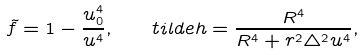Convert formula to latex. <formula><loc_0><loc_0><loc_500><loc_500>\tilde { f } = 1 - \frac { u _ { 0 } ^ { 4 } } { u ^ { 4 } } , \quad t i l d e h = \frac { R ^ { 4 } } { R ^ { 4 } + r ^ { 2 } \triangle ^ { 2 } u ^ { 4 } } ,</formula> 